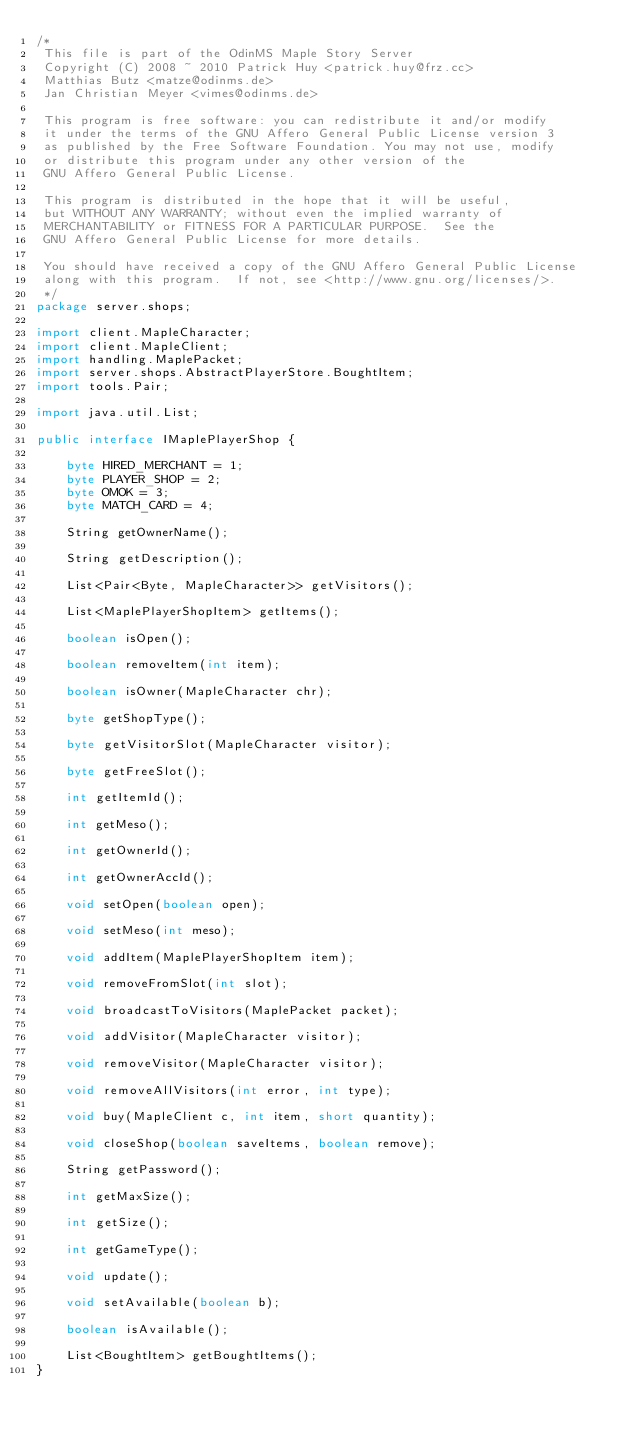Convert code to text. <code><loc_0><loc_0><loc_500><loc_500><_Java_>/*
 This file is part of the OdinMS Maple Story Server
 Copyright (C) 2008 ~ 2010 Patrick Huy <patrick.huy@frz.cc> 
 Matthias Butz <matze@odinms.de>
 Jan Christian Meyer <vimes@odinms.de>

 This program is free software: you can redistribute it and/or modify
 it under the terms of the GNU Affero General Public License version 3
 as published by the Free Software Foundation. You may not use, modify
 or distribute this program under any other version of the
 GNU Affero General Public License.

 This program is distributed in the hope that it will be useful,
 but WITHOUT ANY WARRANTY; without even the implied warranty of
 MERCHANTABILITY or FITNESS FOR A PARTICULAR PURPOSE.  See the
 GNU Affero General Public License for more details.

 You should have received a copy of the GNU Affero General Public License
 along with this program.  If not, see <http://www.gnu.org/licenses/>.
 */
package server.shops;

import client.MapleCharacter;
import client.MapleClient;
import handling.MaplePacket;
import server.shops.AbstractPlayerStore.BoughtItem;
import tools.Pair;

import java.util.List;

public interface IMaplePlayerShop {

    byte HIRED_MERCHANT = 1;
    byte PLAYER_SHOP = 2;
    byte OMOK = 3;
    byte MATCH_CARD = 4;

    String getOwnerName();

    String getDescription();

    List<Pair<Byte, MapleCharacter>> getVisitors();

    List<MaplePlayerShopItem> getItems();

    boolean isOpen();

    boolean removeItem(int item);

    boolean isOwner(MapleCharacter chr);

    byte getShopType();

    byte getVisitorSlot(MapleCharacter visitor);

    byte getFreeSlot();

    int getItemId();

    int getMeso();

    int getOwnerId();

    int getOwnerAccId();

    void setOpen(boolean open);

    void setMeso(int meso);

    void addItem(MaplePlayerShopItem item);

    void removeFromSlot(int slot);

    void broadcastToVisitors(MaplePacket packet);

    void addVisitor(MapleCharacter visitor);

    void removeVisitor(MapleCharacter visitor);

    void removeAllVisitors(int error, int type);

    void buy(MapleClient c, int item, short quantity);

    void closeShop(boolean saveItems, boolean remove);

    String getPassword();

    int getMaxSize();

    int getSize();

    int getGameType();

    void update();

    void setAvailable(boolean b);

    boolean isAvailable();

    List<BoughtItem> getBoughtItems();
}
</code> 